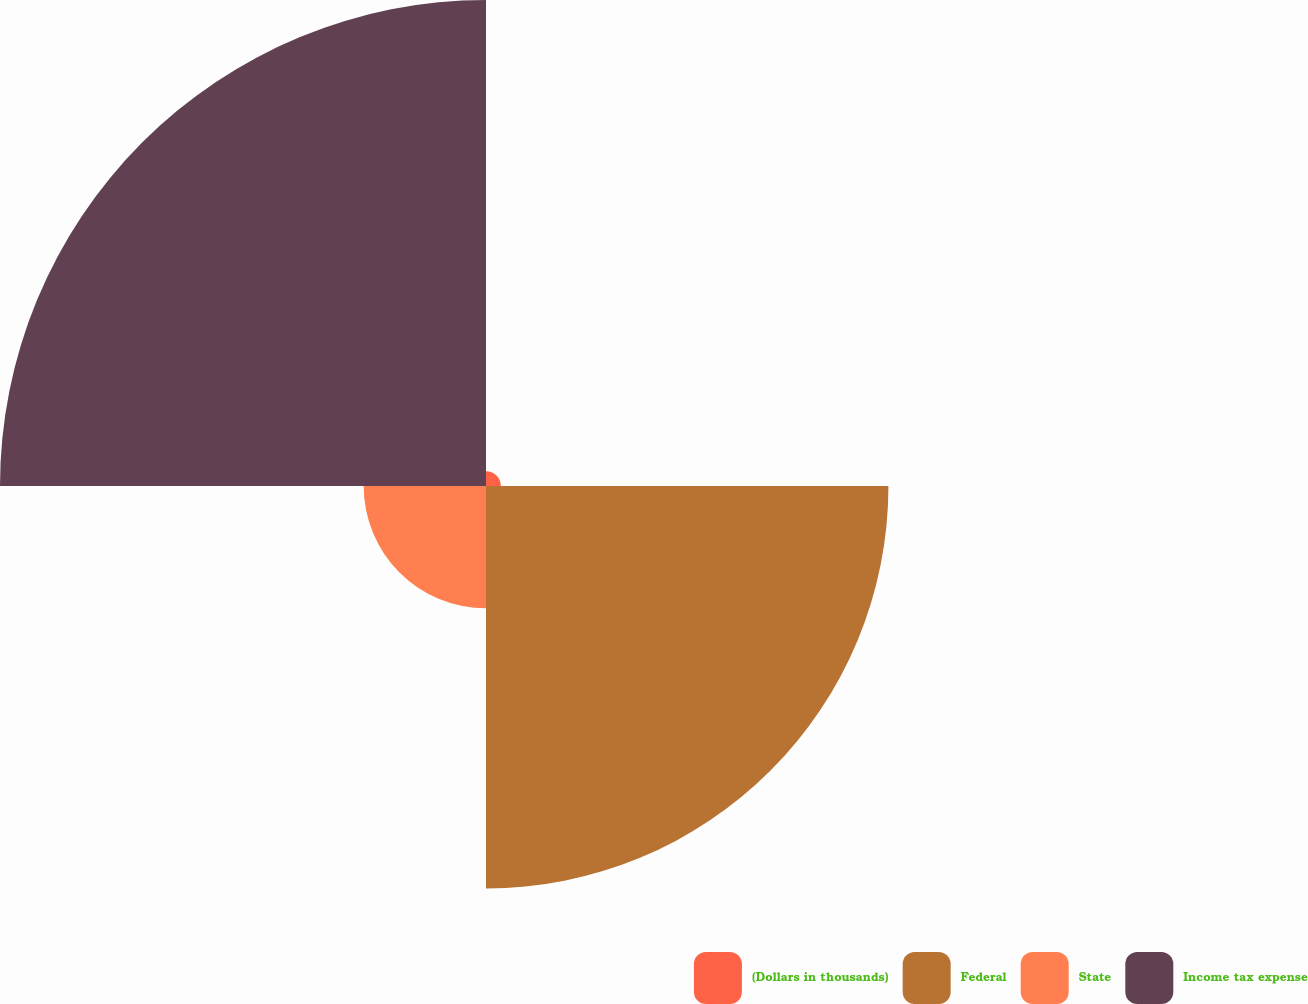Convert chart. <chart><loc_0><loc_0><loc_500><loc_500><pie_chart><fcel>(Dollars in thousands)<fcel>Federal<fcel>State<fcel>Income tax expense<nl><fcel>1.45%<fcel>39.24%<fcel>11.93%<fcel>47.39%<nl></chart> 